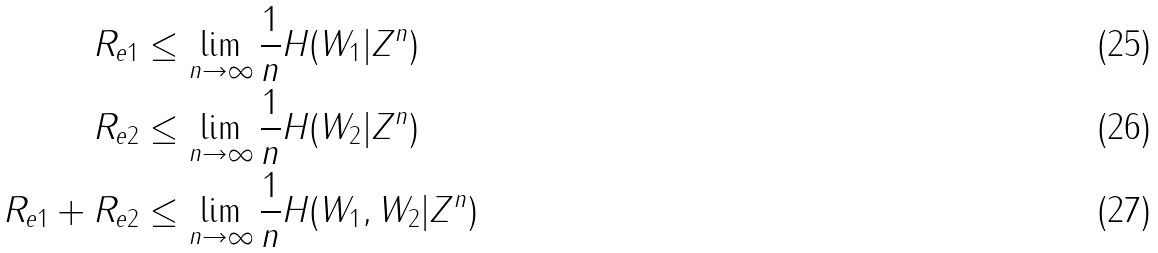Convert formula to latex. <formula><loc_0><loc_0><loc_500><loc_500>R _ { e 1 } & \leq \lim _ { n \rightarrow \infty } \frac { 1 } { n } H ( W _ { 1 } | Z ^ { n } ) \\ R _ { e 2 } & \leq \lim _ { n \rightarrow \infty } \frac { 1 } { n } H ( W _ { 2 } | Z ^ { n } ) \\ R _ { e 1 } + R _ { e 2 } & \leq \lim _ { n \rightarrow \infty } \frac { 1 } { n } H ( W _ { 1 } , W _ { 2 } | Z ^ { n } )</formula> 